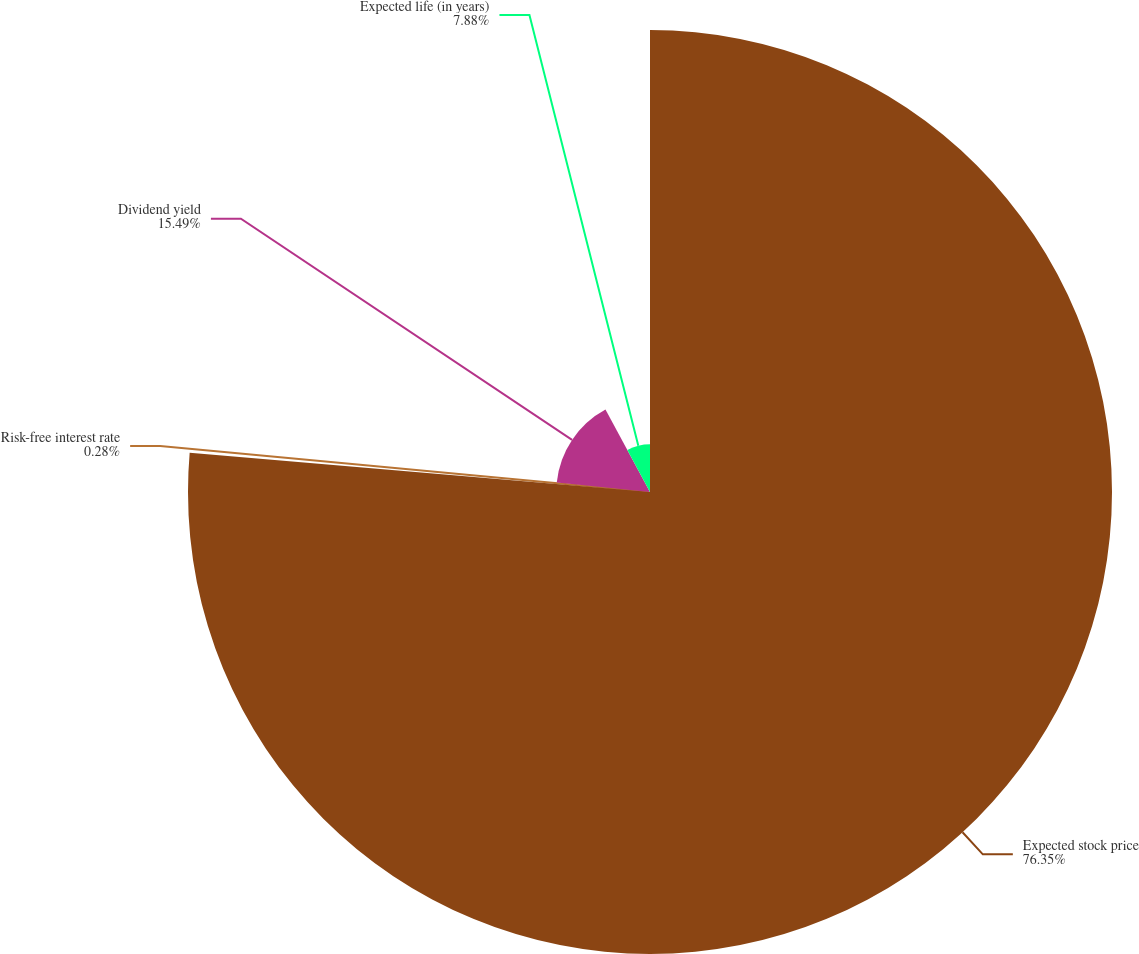Convert chart to OTSL. <chart><loc_0><loc_0><loc_500><loc_500><pie_chart><fcel>Expected stock price<fcel>Risk-free interest rate<fcel>Dividend yield<fcel>Expected life (in years)<nl><fcel>76.35%<fcel>0.28%<fcel>15.49%<fcel>7.88%<nl></chart> 